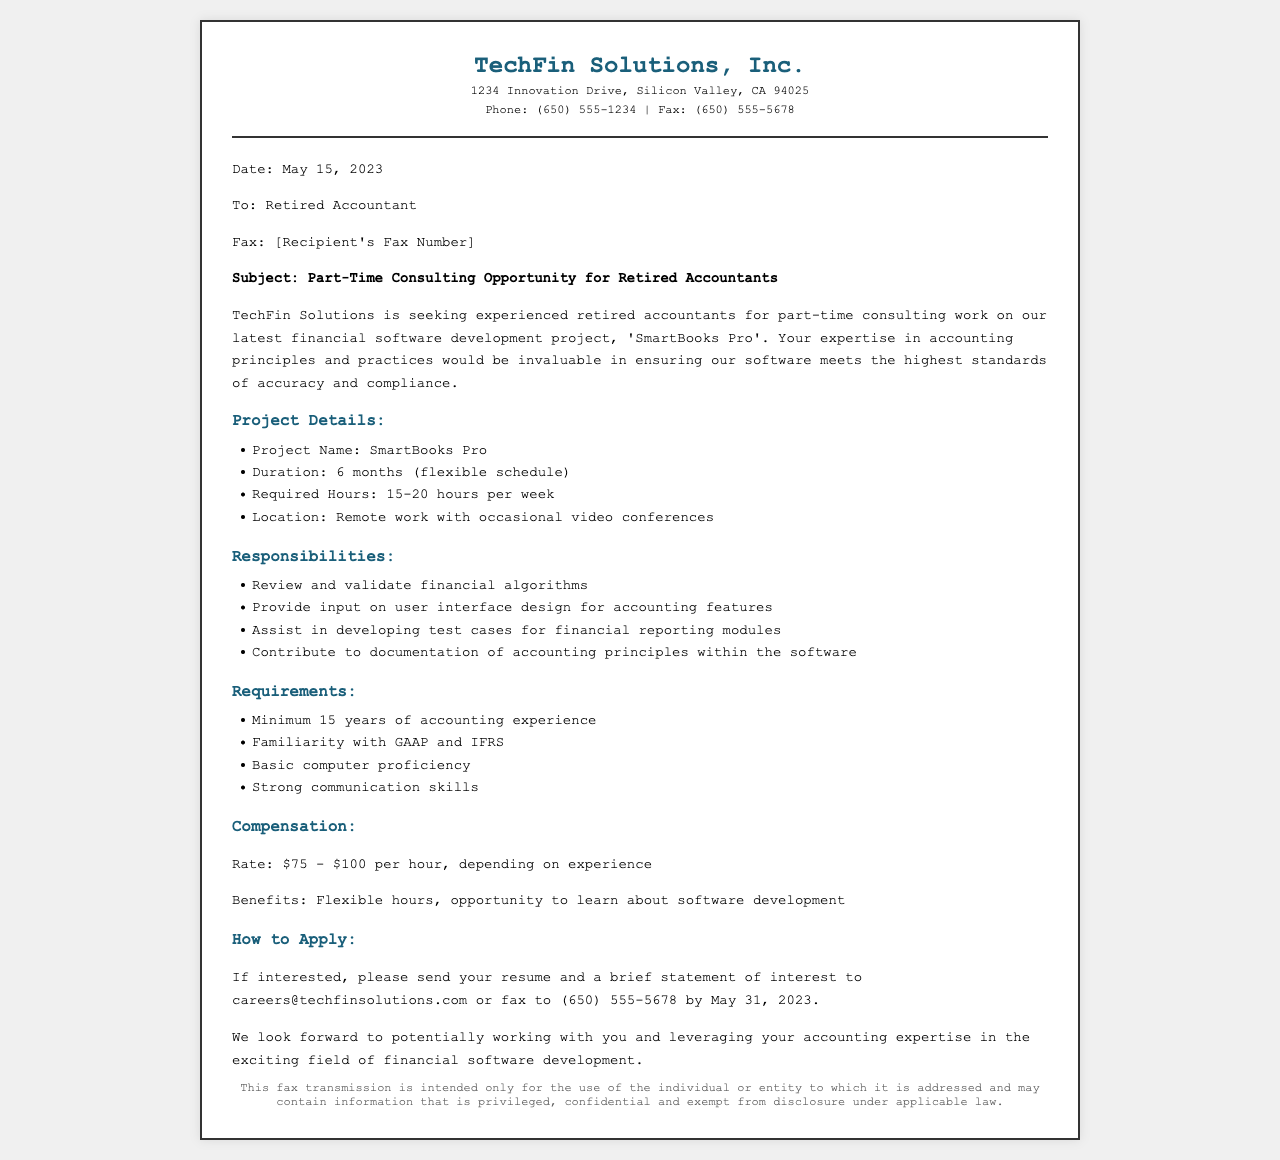What is the project name? The project name is listed in the document under project details.
Answer: SmartBooks Pro What is the required duration of the project? The document states the duration of the project in months.
Answer: 6 months How many hours per week are required for the job? The required hours are mentioned in the project details section of the document.
Answer: 15-20 hours What is the maximum hourly compensation rate? The maximum rate is provided under the compensation section of the document.
Answer: $100 What are the minimum years of accounting experience required? The years of experience needed are specified in the requirements section.
Answer: 15 years What is the email address to apply for the position? The application email is found in the how to apply section of the document.
Answer: careers@techfinsolutions.com What location is specified for the work arrangement? The location information is mentioned within the project details.
Answer: Remote work What kind of skills are necessary for this consulting work? Necessary skills are mentioned in the requirements section of the fax.
Answer: Strong communication skills What is the deadline to submit applications? The application deadline is mentioned in the how to apply section.
Answer: May 31, 2023 